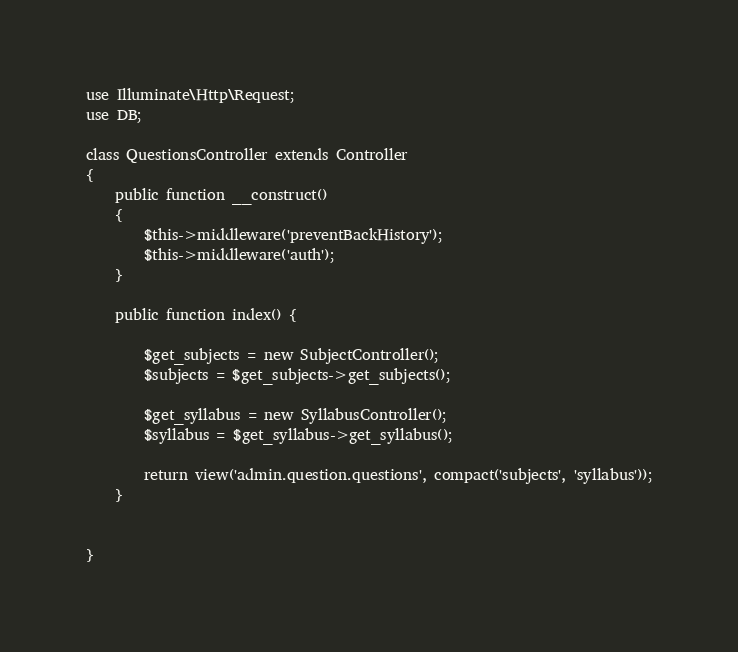<code> <loc_0><loc_0><loc_500><loc_500><_PHP_>
use Illuminate\Http\Request;
use DB;

class QuestionsController extends Controller
{
    public function __construct()
    {
        $this->middleware('preventBackHistory');
        $this->middleware('auth');
    }

    public function index() {

        $get_subjects = new SubjectController();
        $subjects = $get_subjects->get_subjects();

        $get_syllabus = new SyllabusController();
        $syllabus = $get_syllabus->get_syllabus();

        return view('admin.question.questions', compact('subjects', 'syllabus'));
    }


}
</code> 